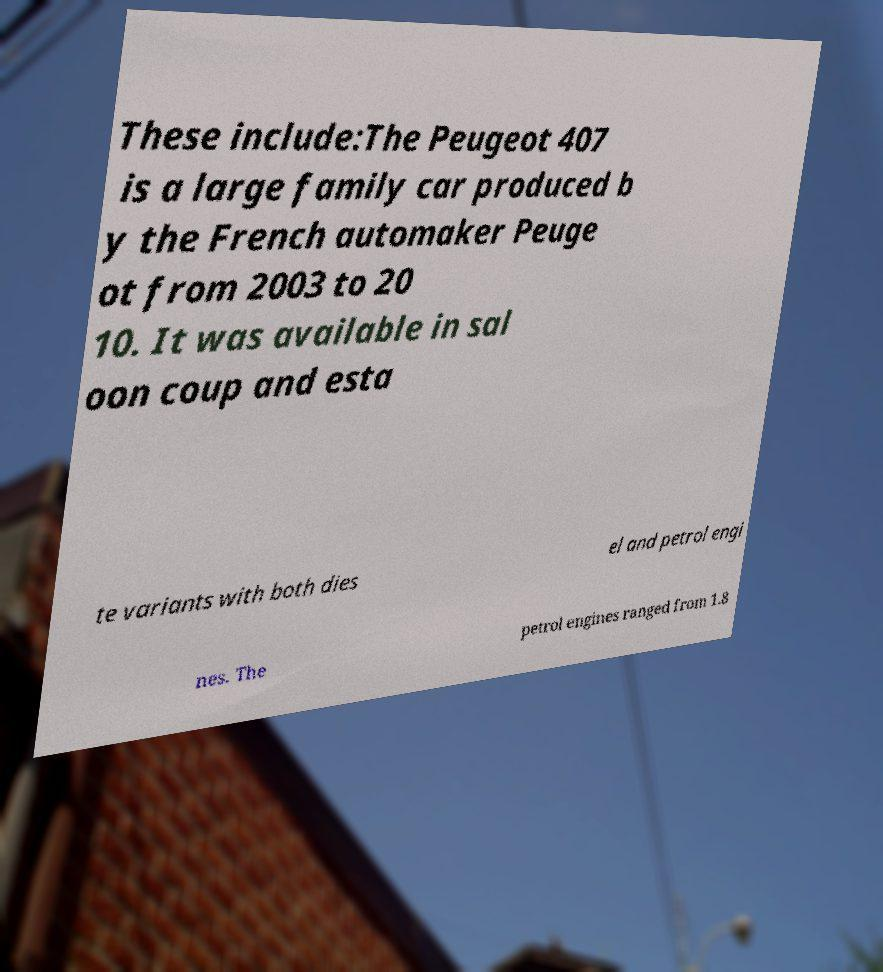Can you accurately transcribe the text from the provided image for me? These include:The Peugeot 407 is a large family car produced b y the French automaker Peuge ot from 2003 to 20 10. It was available in sal oon coup and esta te variants with both dies el and petrol engi nes. The petrol engines ranged from 1.8 